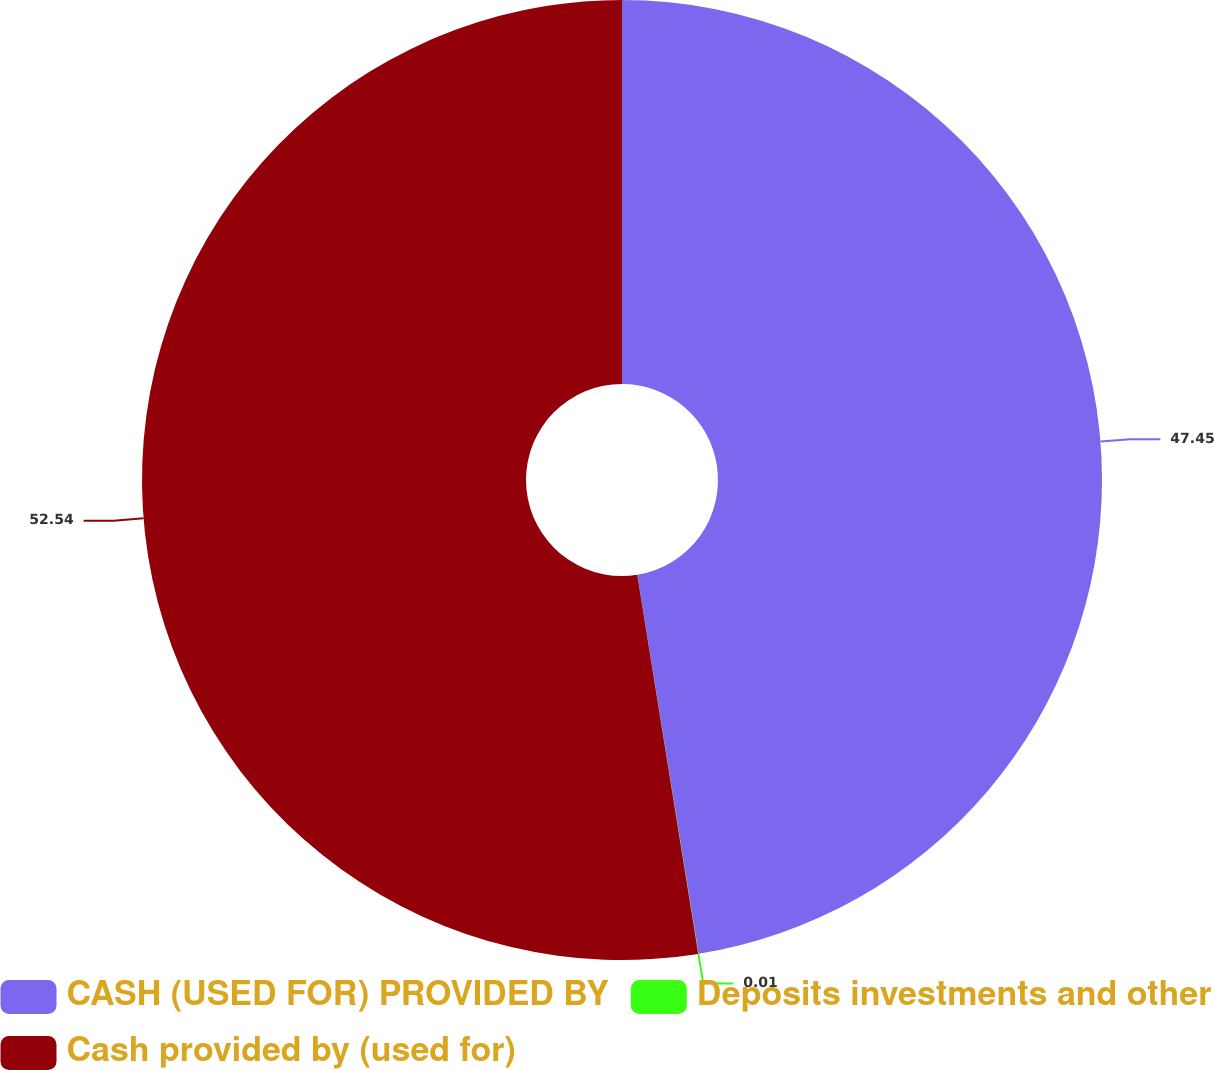<chart> <loc_0><loc_0><loc_500><loc_500><pie_chart><fcel>CASH (USED FOR) PROVIDED BY<fcel>Deposits investments and other<fcel>Cash provided by (used for)<nl><fcel>47.45%<fcel>0.01%<fcel>52.54%<nl></chart> 